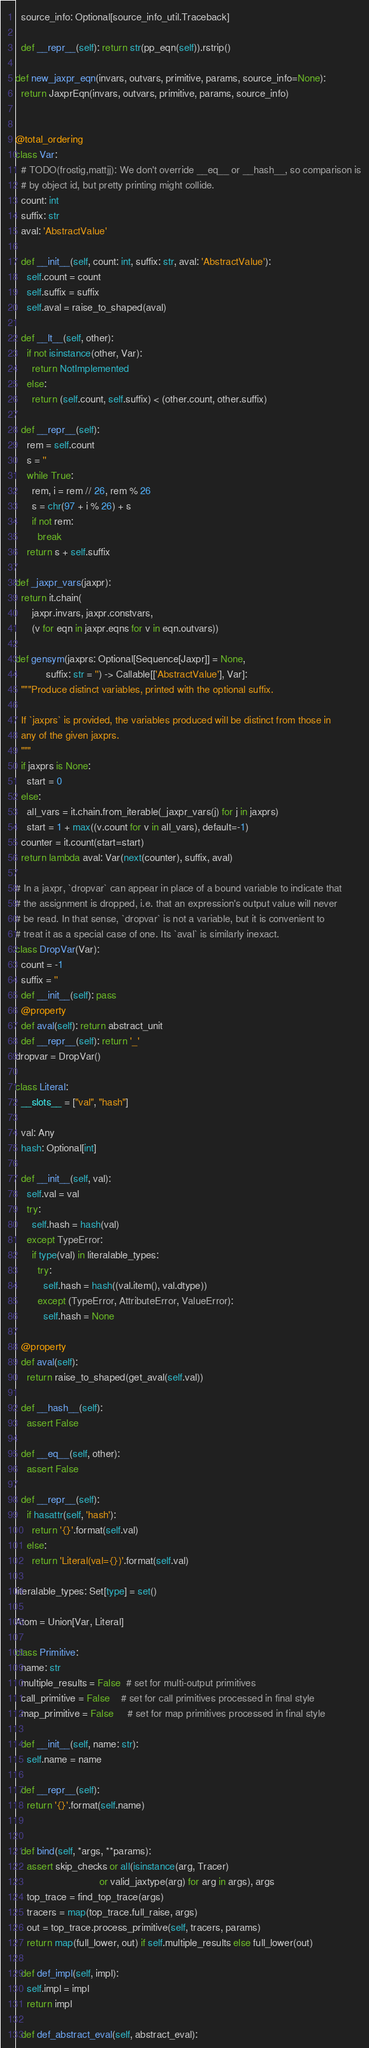<code> <loc_0><loc_0><loc_500><loc_500><_Python_>  source_info: Optional[source_info_util.Traceback]

  def __repr__(self): return str(pp_eqn(self)).rstrip()

def new_jaxpr_eqn(invars, outvars, primitive, params, source_info=None):
  return JaxprEqn(invars, outvars, primitive, params, source_info)


@total_ordering
class Var:
  # TODO(frostig,mattjj): We don't override __eq__ or __hash__, so comparison is
  # by object id, but pretty printing might collide.
  count: int
  suffix: str
  aval: 'AbstractValue'

  def __init__(self, count: int, suffix: str, aval: 'AbstractValue'):
    self.count = count
    self.suffix = suffix
    self.aval = raise_to_shaped(aval)

  def __lt__(self, other):
    if not isinstance(other, Var):
      return NotImplemented
    else:
      return (self.count, self.suffix) < (other.count, other.suffix)

  def __repr__(self):
    rem = self.count
    s = ''
    while True:
      rem, i = rem // 26, rem % 26
      s = chr(97 + i % 26) + s
      if not rem:
        break
    return s + self.suffix

def _jaxpr_vars(jaxpr):
  return it.chain(
      jaxpr.invars, jaxpr.constvars,
      (v for eqn in jaxpr.eqns for v in eqn.outvars))

def gensym(jaxprs: Optional[Sequence[Jaxpr]] = None,
           suffix: str = '') -> Callable[['AbstractValue'], Var]:
  """Produce distinct variables, printed with the optional suffix.

  If `jaxprs` is provided, the variables produced will be distinct from those in
  any of the given jaxprs.
  """
  if jaxprs is None:
    start = 0
  else:
    all_vars = it.chain.from_iterable(_jaxpr_vars(j) for j in jaxprs)
    start = 1 + max((v.count for v in all_vars), default=-1)
  counter = it.count(start=start)
  return lambda aval: Var(next(counter), suffix, aval)

# In a jaxpr, `dropvar` can appear in place of a bound variable to indicate that
# the assignment is dropped, i.e. that an expression's output value will never
# be read. In that sense, `dropvar` is not a variable, but it is convenient to
# treat it as a special case of one. Its `aval` is similarly inexact.
class DropVar(Var):
  count = -1
  suffix = ''
  def __init__(self): pass
  @property
  def aval(self): return abstract_unit
  def __repr__(self): return '_'
dropvar = DropVar()

class Literal:
  __slots__ = ["val", "hash"]

  val: Any
  hash: Optional[int]

  def __init__(self, val):
    self.val = val
    try:
      self.hash = hash(val)
    except TypeError:
      if type(val) in literalable_types:
        try:
          self.hash = hash((val.item(), val.dtype))
        except (TypeError, AttributeError, ValueError):
          self.hash = None

  @property
  def aval(self):
    return raise_to_shaped(get_aval(self.val))

  def __hash__(self):
    assert False

  def __eq__(self, other):
    assert False

  def __repr__(self):
    if hasattr(self, 'hash'):
      return '{}'.format(self.val)
    else:
      return 'Literal(val={})'.format(self.val)

literalable_types: Set[type] = set()

Atom = Union[Var, Literal]

class Primitive:
  name: str
  multiple_results = False  # set for multi-output primitives
  call_primitive = False    # set for call primitives processed in final style
  map_primitive = False     # set for map primitives processed in final style

  def __init__(self, name: str):
    self.name = name

  def __repr__(self):
    return '{}'.format(self.name)


  def bind(self, *args, **params):
    assert skip_checks or all(isinstance(arg, Tracer)
                              or valid_jaxtype(arg) for arg in args), args
    top_trace = find_top_trace(args)
    tracers = map(top_trace.full_raise, args)
    out = top_trace.process_primitive(self, tracers, params)
    return map(full_lower, out) if self.multiple_results else full_lower(out)

  def def_impl(self, impl):
    self.impl = impl
    return impl

  def def_abstract_eval(self, abstract_eval):</code> 